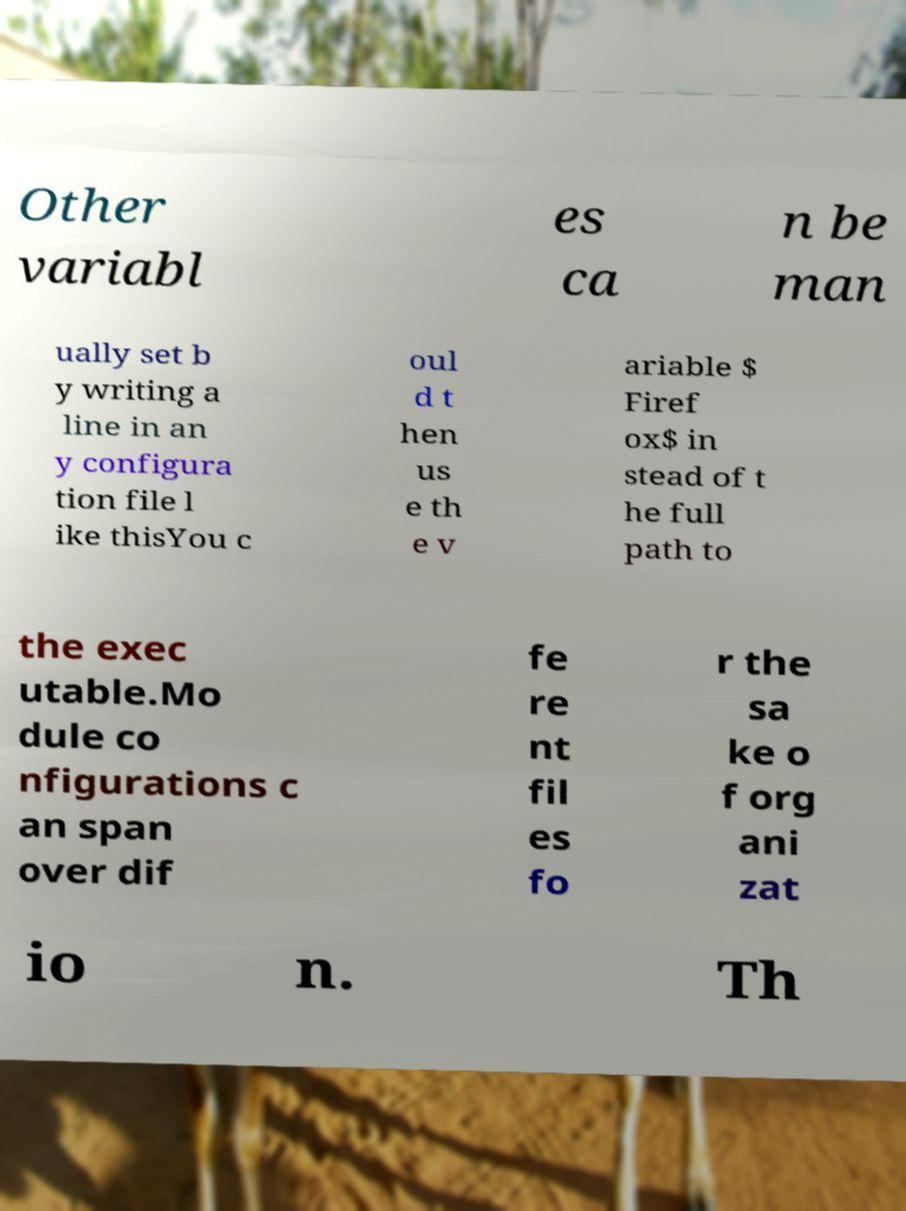What messages or text are displayed in this image? I need them in a readable, typed format. Other variabl es ca n be man ually set b y writing a line in an y configura tion file l ike thisYou c oul d t hen us e th e v ariable $ Firef ox$ in stead of t he full path to the exec utable.Mo dule co nfigurations c an span over dif fe re nt fil es fo r the sa ke o f org ani zat io n. Th 